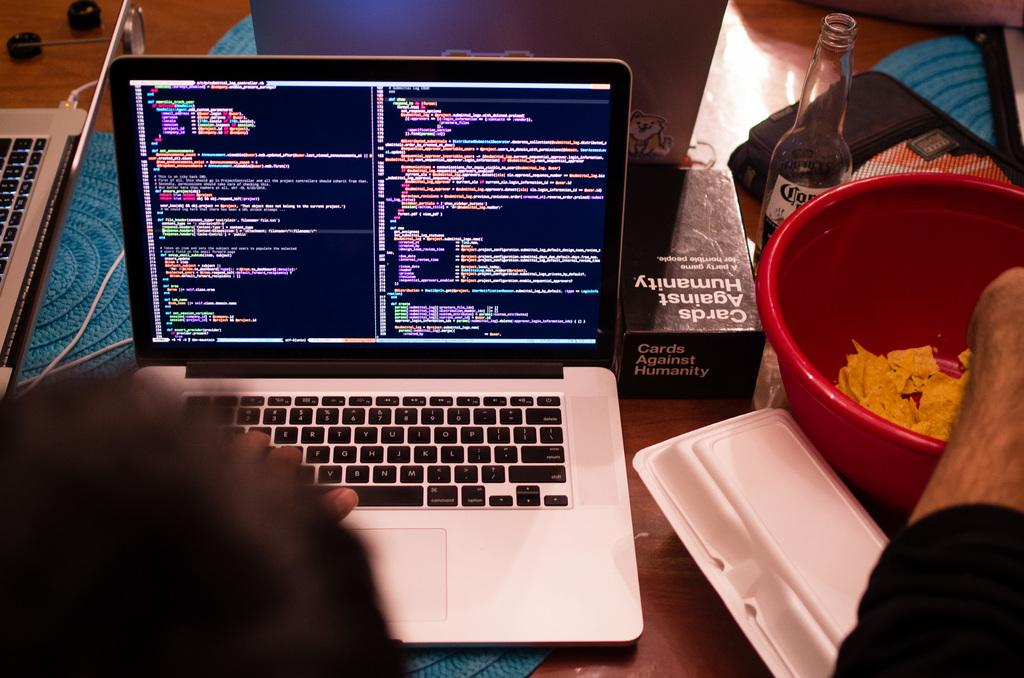<image>
Share a concise interpretation of the image provided. An open laptop next to a box of Cards against humanity 